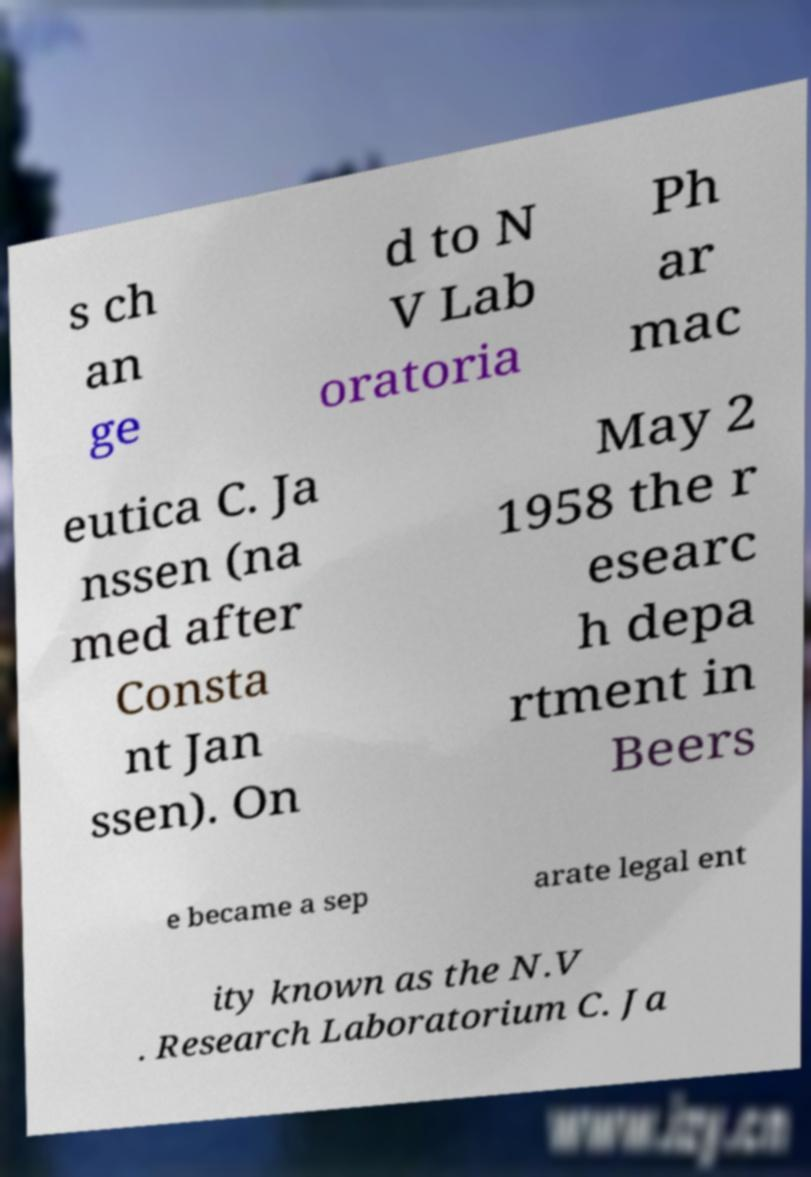For documentation purposes, I need the text within this image transcribed. Could you provide that? s ch an ge d to N V Lab oratoria Ph ar mac eutica C. Ja nssen (na med after Consta nt Jan ssen). On May 2 1958 the r esearc h depa rtment in Beers e became a sep arate legal ent ity known as the N.V . Research Laboratorium C. Ja 